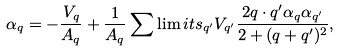Convert formula to latex. <formula><loc_0><loc_0><loc_500><loc_500>\alpha _ { q } = - { \frac { V _ { q } } { A _ { q } } } + { \frac { 1 } { A _ { q } } } \sum \lim i t s _ { { q } ^ { \prime } } V _ { { q } ^ { \prime } } \frac { 2 { q \cdot q } ^ { \prime } \alpha _ { q } \alpha _ { { q } ^ { \prime } } } { 2 + ( { q } + { q } ^ { \prime } ) ^ { 2 } } ,</formula> 